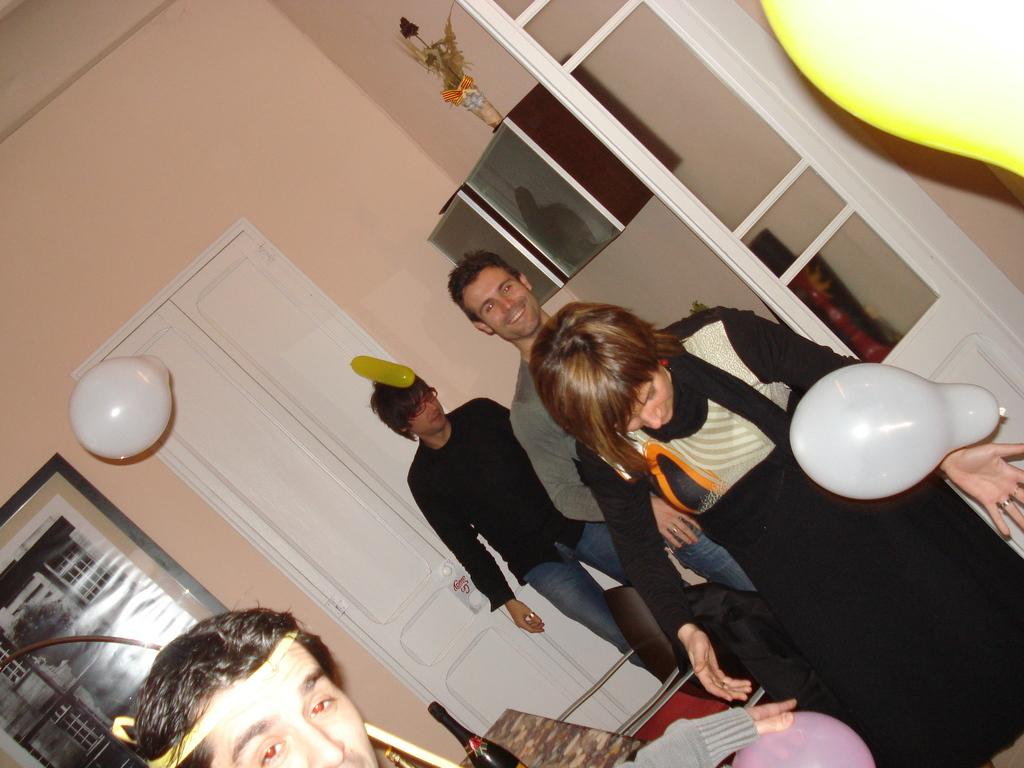How many people are in the image? There is a group of people in the image. Where are the people located? The people are standing in a room. What decorations can be seen in the room? Balloons are present in the room. What are some of the features of the room? There is a door and a cupboard in the room. What is placed on top of the cupboard? A flower vase is on top of the cupboard. What type of disease is affecting the nerves of the people in the image? There is no indication of any disease or nerve issues in the image; it simply shows a group of people standing in a room with balloons and other objects. 